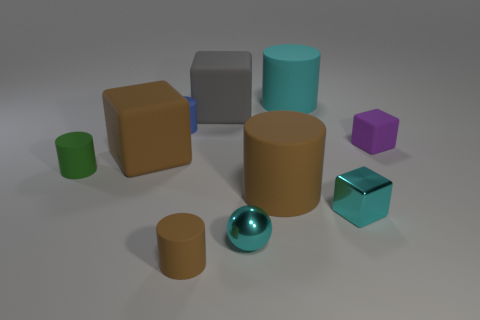There is a cyan object behind the matte block that is right of the cyan cylinder; what is its shape?
Make the answer very short. Cylinder. Is the color of the tiny shiny cube the same as the small ball?
Keep it short and to the point. Yes. What number of spheres are either big cyan things or tiny cyan shiny things?
Offer a very short reply. 1. What is the material of the tiny thing that is both to the right of the large gray rubber object and to the left of the large cyan cylinder?
Keep it short and to the point. Metal. There is a small cyan sphere; what number of rubber cylinders are on the right side of it?
Provide a succinct answer. 2. Do the brown object in front of the shiny sphere and the big cube to the left of the large gray rubber cube have the same material?
Your answer should be compact. Yes. How many objects are either objects behind the purple block or big matte blocks?
Keep it short and to the point. 4. Is the number of big gray matte things in front of the tiny blue cylinder less than the number of cyan balls behind the small green matte cylinder?
Provide a short and direct response. No. What number of other things are the same size as the gray block?
Keep it short and to the point. 3. Is the blue object made of the same material as the small cyan object that is left of the big cyan matte thing?
Your answer should be very brief. No. 